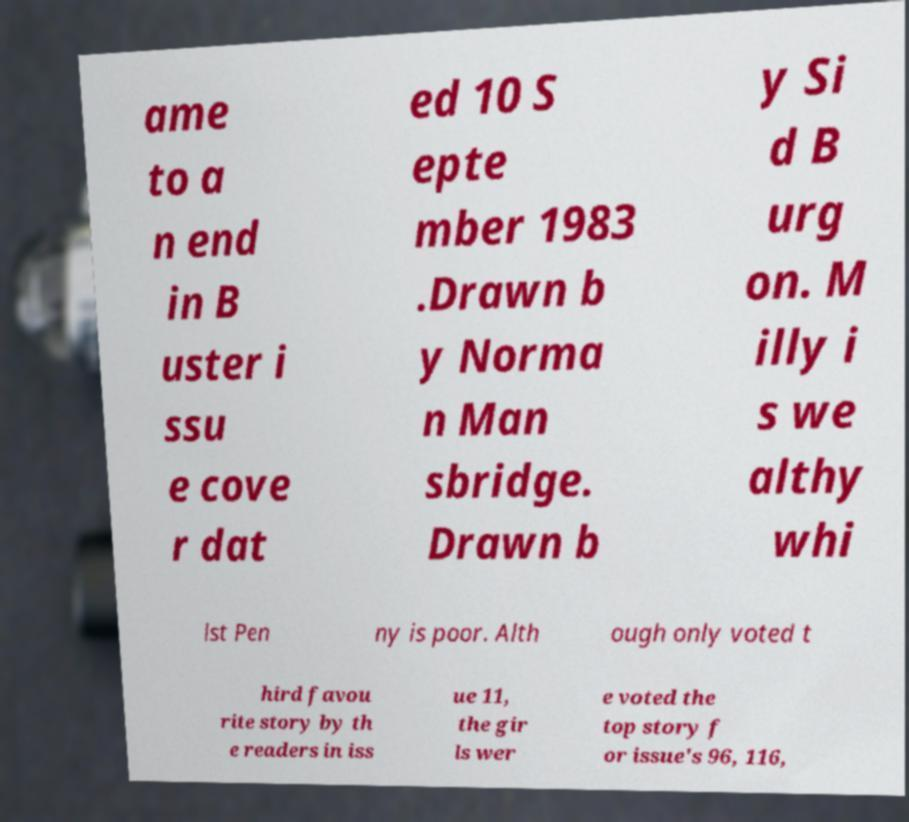Could you assist in decoding the text presented in this image and type it out clearly? ame to a n end in B uster i ssu e cove r dat ed 10 S epte mber 1983 .Drawn b y Norma n Man sbridge. Drawn b y Si d B urg on. M illy i s we althy whi lst Pen ny is poor. Alth ough only voted t hird favou rite story by th e readers in iss ue 11, the gir ls wer e voted the top story f or issue's 96, 116, 